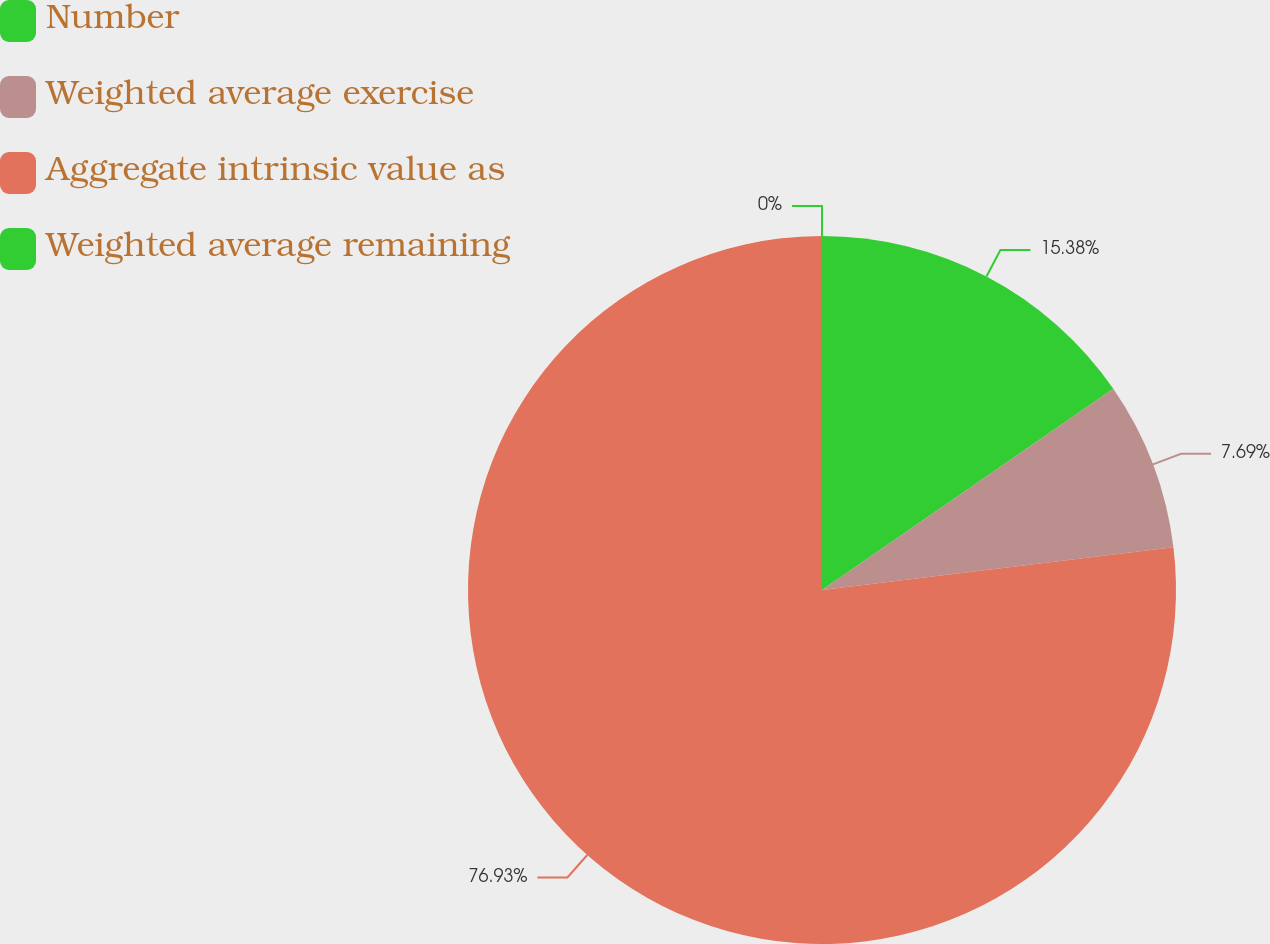Convert chart. <chart><loc_0><loc_0><loc_500><loc_500><pie_chart><fcel>Number<fcel>Weighted average exercise<fcel>Aggregate intrinsic value as<fcel>Weighted average remaining<nl><fcel>15.38%<fcel>7.69%<fcel>76.92%<fcel>0.0%<nl></chart> 